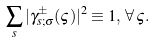<formula> <loc_0><loc_0><loc_500><loc_500>\sum _ { s } | \gamma ^ { \pm } _ { s ; \sigma } ( \varsigma ) | ^ { 2 } \equiv 1 , \, \forall \, \varsigma .</formula> 